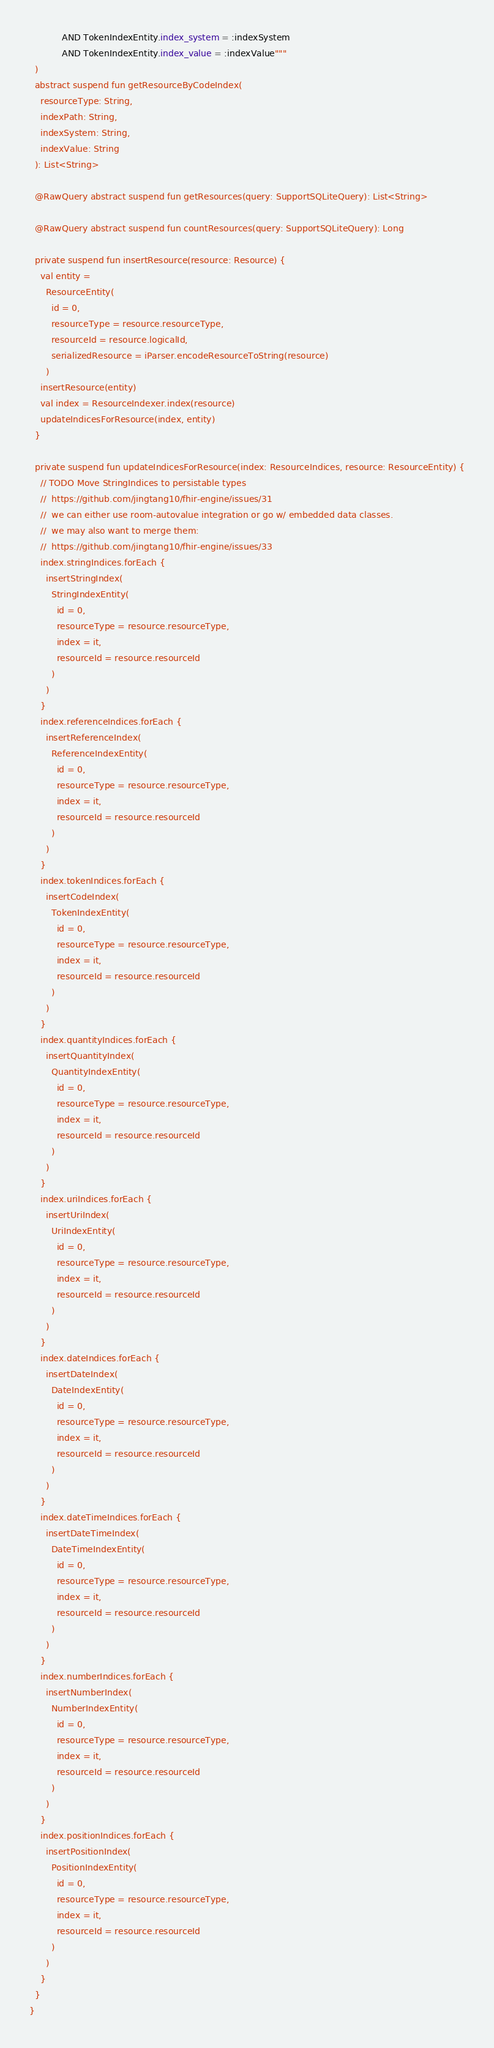<code> <loc_0><loc_0><loc_500><loc_500><_Kotlin_>            AND TokenIndexEntity.index_system = :indexSystem
            AND TokenIndexEntity.index_value = :indexValue"""
  )
  abstract suspend fun getResourceByCodeIndex(
    resourceType: String,
    indexPath: String,
    indexSystem: String,
    indexValue: String
  ): List<String>

  @RawQuery abstract suspend fun getResources(query: SupportSQLiteQuery): List<String>

  @RawQuery abstract suspend fun countResources(query: SupportSQLiteQuery): Long

  private suspend fun insertResource(resource: Resource) {
    val entity =
      ResourceEntity(
        id = 0,
        resourceType = resource.resourceType,
        resourceId = resource.logicalId,
        serializedResource = iParser.encodeResourceToString(resource)
      )
    insertResource(entity)
    val index = ResourceIndexer.index(resource)
    updateIndicesForResource(index, entity)
  }

  private suspend fun updateIndicesForResource(index: ResourceIndices, resource: ResourceEntity) {
    // TODO Move StringIndices to persistable types
    //  https://github.com/jingtang10/fhir-engine/issues/31
    //  we can either use room-autovalue integration or go w/ embedded data classes.
    //  we may also want to merge them:
    //  https://github.com/jingtang10/fhir-engine/issues/33
    index.stringIndices.forEach {
      insertStringIndex(
        StringIndexEntity(
          id = 0,
          resourceType = resource.resourceType,
          index = it,
          resourceId = resource.resourceId
        )
      )
    }
    index.referenceIndices.forEach {
      insertReferenceIndex(
        ReferenceIndexEntity(
          id = 0,
          resourceType = resource.resourceType,
          index = it,
          resourceId = resource.resourceId
        )
      )
    }
    index.tokenIndices.forEach {
      insertCodeIndex(
        TokenIndexEntity(
          id = 0,
          resourceType = resource.resourceType,
          index = it,
          resourceId = resource.resourceId
        )
      )
    }
    index.quantityIndices.forEach {
      insertQuantityIndex(
        QuantityIndexEntity(
          id = 0,
          resourceType = resource.resourceType,
          index = it,
          resourceId = resource.resourceId
        )
      )
    }
    index.uriIndices.forEach {
      insertUriIndex(
        UriIndexEntity(
          id = 0,
          resourceType = resource.resourceType,
          index = it,
          resourceId = resource.resourceId
        )
      )
    }
    index.dateIndices.forEach {
      insertDateIndex(
        DateIndexEntity(
          id = 0,
          resourceType = resource.resourceType,
          index = it,
          resourceId = resource.resourceId
        )
      )
    }
    index.dateTimeIndices.forEach {
      insertDateTimeIndex(
        DateTimeIndexEntity(
          id = 0,
          resourceType = resource.resourceType,
          index = it,
          resourceId = resource.resourceId
        )
      )
    }
    index.numberIndices.forEach {
      insertNumberIndex(
        NumberIndexEntity(
          id = 0,
          resourceType = resource.resourceType,
          index = it,
          resourceId = resource.resourceId
        )
      )
    }
    index.positionIndices.forEach {
      insertPositionIndex(
        PositionIndexEntity(
          id = 0,
          resourceType = resource.resourceType,
          index = it,
          resourceId = resource.resourceId
        )
      )
    }
  }
}
</code> 